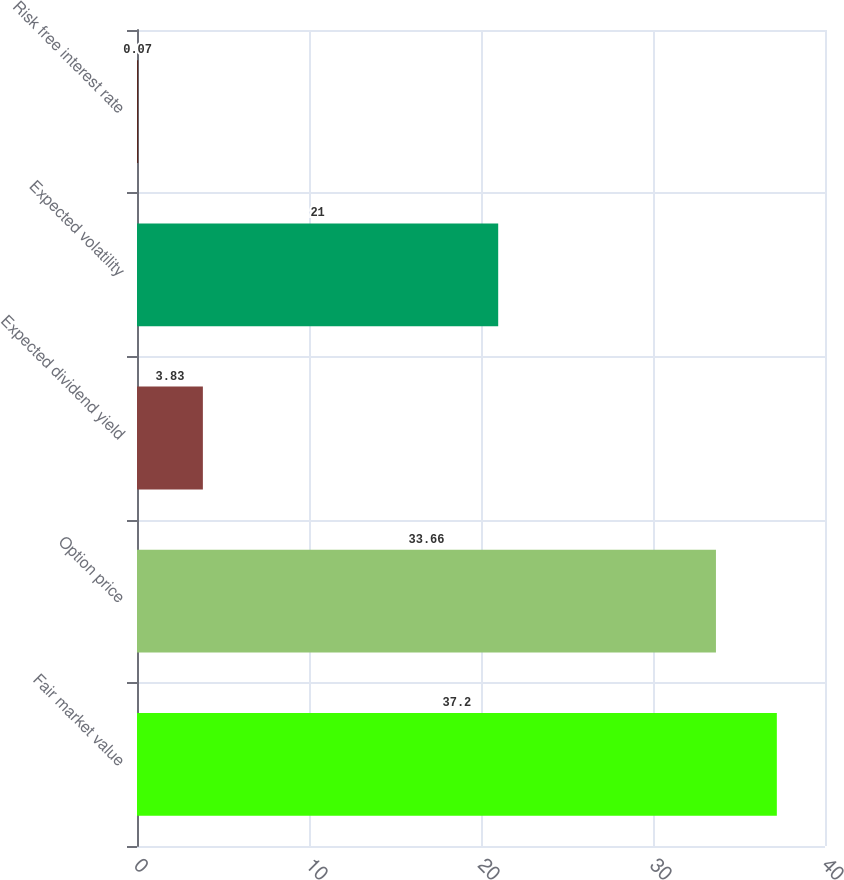<chart> <loc_0><loc_0><loc_500><loc_500><bar_chart><fcel>Fair market value<fcel>Option price<fcel>Expected dividend yield<fcel>Expected volatility<fcel>Risk free interest rate<nl><fcel>37.2<fcel>33.66<fcel>3.83<fcel>21<fcel>0.07<nl></chart> 